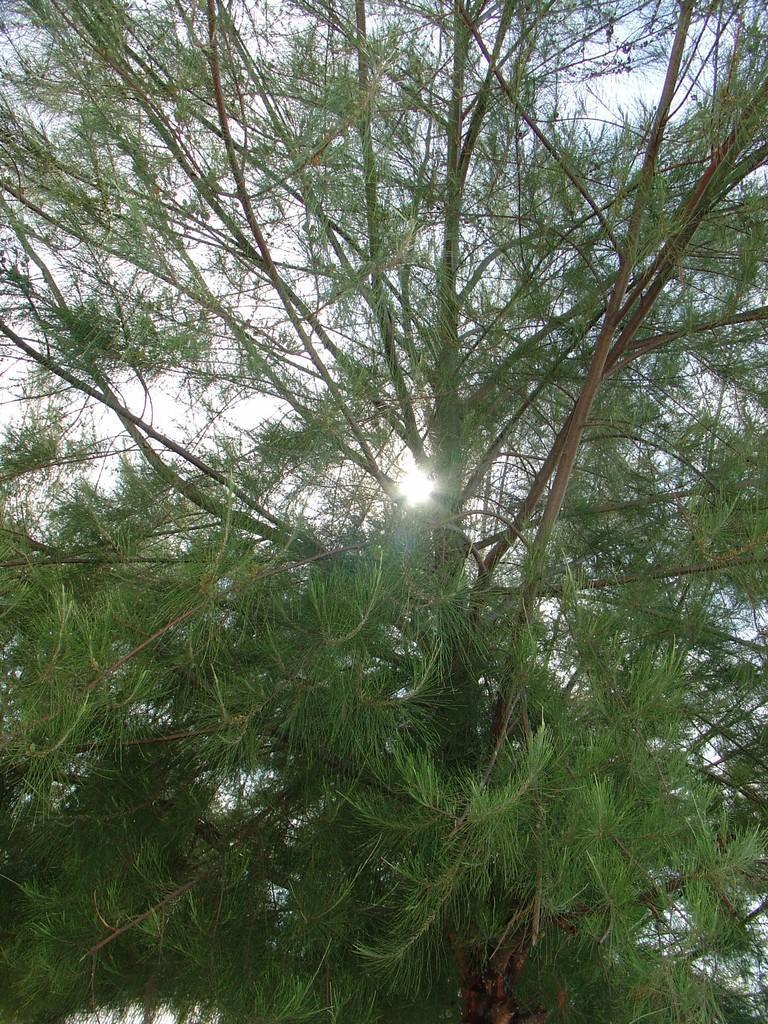In one or two sentences, can you explain what this image depicts? In this image we can see a tree and the sky which looks cloudy. 